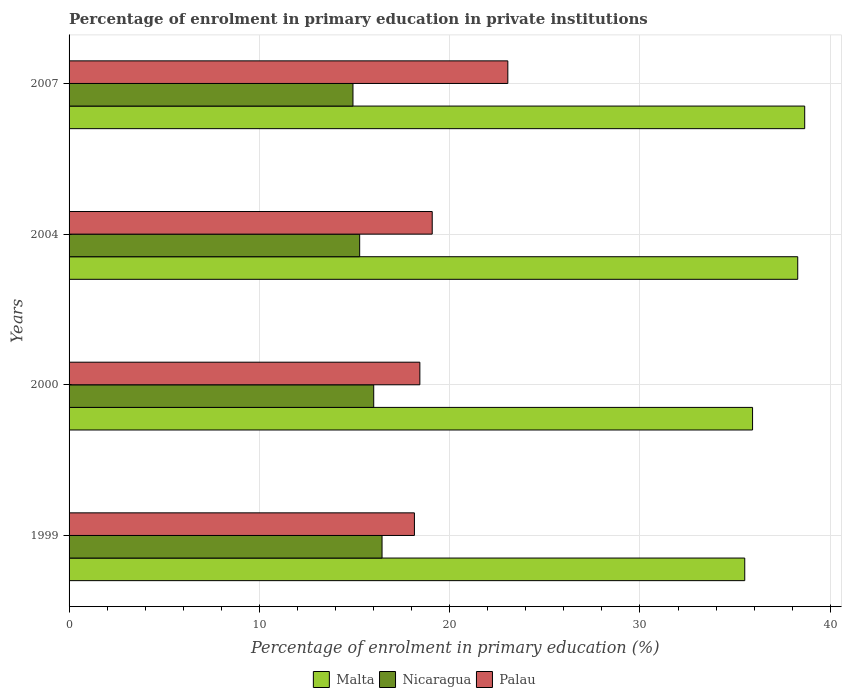How many different coloured bars are there?
Offer a very short reply. 3. How many groups of bars are there?
Give a very brief answer. 4. Are the number of bars on each tick of the Y-axis equal?
Offer a very short reply. Yes. How many bars are there on the 4th tick from the bottom?
Ensure brevity in your answer.  3. What is the label of the 1st group of bars from the top?
Offer a terse response. 2007. What is the percentage of enrolment in primary education in Palau in 2004?
Provide a short and direct response. 19.08. Across all years, what is the maximum percentage of enrolment in primary education in Nicaragua?
Make the answer very short. 16.45. Across all years, what is the minimum percentage of enrolment in primary education in Malta?
Your response must be concise. 35.51. In which year was the percentage of enrolment in primary education in Palau maximum?
Your answer should be compact. 2007. In which year was the percentage of enrolment in primary education in Nicaragua minimum?
Provide a short and direct response. 2007. What is the total percentage of enrolment in primary education in Malta in the graph?
Make the answer very short. 148.38. What is the difference between the percentage of enrolment in primary education in Nicaragua in 1999 and that in 2004?
Offer a very short reply. 1.18. What is the difference between the percentage of enrolment in primary education in Nicaragua in 2000 and the percentage of enrolment in primary education in Malta in 1999?
Offer a very short reply. -19.5. What is the average percentage of enrolment in primary education in Palau per year?
Ensure brevity in your answer.  19.68. In the year 2004, what is the difference between the percentage of enrolment in primary education in Malta and percentage of enrolment in primary education in Palau?
Give a very brief answer. 19.21. What is the ratio of the percentage of enrolment in primary education in Malta in 2000 to that in 2004?
Offer a terse response. 0.94. What is the difference between the highest and the second highest percentage of enrolment in primary education in Nicaragua?
Your response must be concise. 0.44. What is the difference between the highest and the lowest percentage of enrolment in primary education in Nicaragua?
Keep it short and to the point. 1.53. In how many years, is the percentage of enrolment in primary education in Nicaragua greater than the average percentage of enrolment in primary education in Nicaragua taken over all years?
Keep it short and to the point. 2. Is the sum of the percentage of enrolment in primary education in Nicaragua in 1999 and 2000 greater than the maximum percentage of enrolment in primary education in Palau across all years?
Your response must be concise. Yes. What does the 1st bar from the top in 2004 represents?
Your response must be concise. Palau. What does the 3rd bar from the bottom in 2004 represents?
Keep it short and to the point. Palau. Is it the case that in every year, the sum of the percentage of enrolment in primary education in Palau and percentage of enrolment in primary education in Malta is greater than the percentage of enrolment in primary education in Nicaragua?
Keep it short and to the point. Yes. How many bars are there?
Make the answer very short. 12. Are all the bars in the graph horizontal?
Your answer should be very brief. Yes. How many years are there in the graph?
Offer a terse response. 4. What is the title of the graph?
Keep it short and to the point. Percentage of enrolment in primary education in private institutions. Does "Sub-Saharan Africa (all income levels)" appear as one of the legend labels in the graph?
Provide a succinct answer. No. What is the label or title of the X-axis?
Make the answer very short. Percentage of enrolment in primary education (%). What is the label or title of the Y-axis?
Your response must be concise. Years. What is the Percentage of enrolment in primary education (%) in Malta in 1999?
Provide a short and direct response. 35.51. What is the Percentage of enrolment in primary education (%) of Nicaragua in 1999?
Your answer should be compact. 16.45. What is the Percentage of enrolment in primary education (%) of Palau in 1999?
Offer a terse response. 18.15. What is the Percentage of enrolment in primary education (%) of Malta in 2000?
Your answer should be compact. 35.92. What is the Percentage of enrolment in primary education (%) in Nicaragua in 2000?
Your response must be concise. 16.01. What is the Percentage of enrolment in primary education (%) in Palau in 2000?
Keep it short and to the point. 18.43. What is the Percentage of enrolment in primary education (%) in Malta in 2004?
Your response must be concise. 38.29. What is the Percentage of enrolment in primary education (%) in Nicaragua in 2004?
Ensure brevity in your answer.  15.27. What is the Percentage of enrolment in primary education (%) in Palau in 2004?
Your answer should be very brief. 19.08. What is the Percentage of enrolment in primary education (%) in Malta in 2007?
Your answer should be very brief. 38.66. What is the Percentage of enrolment in primary education (%) in Nicaragua in 2007?
Your response must be concise. 14.92. What is the Percentage of enrolment in primary education (%) in Palau in 2007?
Keep it short and to the point. 23.06. Across all years, what is the maximum Percentage of enrolment in primary education (%) in Malta?
Provide a succinct answer. 38.66. Across all years, what is the maximum Percentage of enrolment in primary education (%) in Nicaragua?
Your response must be concise. 16.45. Across all years, what is the maximum Percentage of enrolment in primary education (%) of Palau?
Keep it short and to the point. 23.06. Across all years, what is the minimum Percentage of enrolment in primary education (%) of Malta?
Provide a succinct answer. 35.51. Across all years, what is the minimum Percentage of enrolment in primary education (%) of Nicaragua?
Your answer should be compact. 14.92. Across all years, what is the minimum Percentage of enrolment in primary education (%) in Palau?
Make the answer very short. 18.15. What is the total Percentage of enrolment in primary education (%) in Malta in the graph?
Your response must be concise. 148.38. What is the total Percentage of enrolment in primary education (%) in Nicaragua in the graph?
Your answer should be very brief. 62.65. What is the total Percentage of enrolment in primary education (%) of Palau in the graph?
Provide a short and direct response. 78.72. What is the difference between the Percentage of enrolment in primary education (%) in Malta in 1999 and that in 2000?
Give a very brief answer. -0.41. What is the difference between the Percentage of enrolment in primary education (%) of Nicaragua in 1999 and that in 2000?
Keep it short and to the point. 0.44. What is the difference between the Percentage of enrolment in primary education (%) of Palau in 1999 and that in 2000?
Provide a short and direct response. -0.29. What is the difference between the Percentage of enrolment in primary education (%) of Malta in 1999 and that in 2004?
Make the answer very short. -2.78. What is the difference between the Percentage of enrolment in primary education (%) of Nicaragua in 1999 and that in 2004?
Make the answer very short. 1.18. What is the difference between the Percentage of enrolment in primary education (%) in Palau in 1999 and that in 2004?
Give a very brief answer. -0.94. What is the difference between the Percentage of enrolment in primary education (%) of Malta in 1999 and that in 2007?
Your response must be concise. -3.15. What is the difference between the Percentage of enrolment in primary education (%) of Nicaragua in 1999 and that in 2007?
Your answer should be compact. 1.53. What is the difference between the Percentage of enrolment in primary education (%) in Palau in 1999 and that in 2007?
Your answer should be compact. -4.91. What is the difference between the Percentage of enrolment in primary education (%) of Malta in 2000 and that in 2004?
Ensure brevity in your answer.  -2.37. What is the difference between the Percentage of enrolment in primary education (%) in Nicaragua in 2000 and that in 2004?
Keep it short and to the point. 0.74. What is the difference between the Percentage of enrolment in primary education (%) in Palau in 2000 and that in 2004?
Give a very brief answer. -0.65. What is the difference between the Percentage of enrolment in primary education (%) of Malta in 2000 and that in 2007?
Give a very brief answer. -2.74. What is the difference between the Percentage of enrolment in primary education (%) of Nicaragua in 2000 and that in 2007?
Offer a very short reply. 1.09. What is the difference between the Percentage of enrolment in primary education (%) in Palau in 2000 and that in 2007?
Provide a succinct answer. -4.62. What is the difference between the Percentage of enrolment in primary education (%) in Malta in 2004 and that in 2007?
Offer a terse response. -0.37. What is the difference between the Percentage of enrolment in primary education (%) in Nicaragua in 2004 and that in 2007?
Your response must be concise. 0.35. What is the difference between the Percentage of enrolment in primary education (%) of Palau in 2004 and that in 2007?
Your answer should be compact. -3.97. What is the difference between the Percentage of enrolment in primary education (%) of Malta in 1999 and the Percentage of enrolment in primary education (%) of Nicaragua in 2000?
Your answer should be very brief. 19.5. What is the difference between the Percentage of enrolment in primary education (%) of Malta in 1999 and the Percentage of enrolment in primary education (%) of Palau in 2000?
Offer a terse response. 17.07. What is the difference between the Percentage of enrolment in primary education (%) in Nicaragua in 1999 and the Percentage of enrolment in primary education (%) in Palau in 2000?
Offer a terse response. -1.99. What is the difference between the Percentage of enrolment in primary education (%) of Malta in 1999 and the Percentage of enrolment in primary education (%) of Nicaragua in 2004?
Your answer should be very brief. 20.24. What is the difference between the Percentage of enrolment in primary education (%) in Malta in 1999 and the Percentage of enrolment in primary education (%) in Palau in 2004?
Give a very brief answer. 16.42. What is the difference between the Percentage of enrolment in primary education (%) in Nicaragua in 1999 and the Percentage of enrolment in primary education (%) in Palau in 2004?
Provide a short and direct response. -2.64. What is the difference between the Percentage of enrolment in primary education (%) in Malta in 1999 and the Percentage of enrolment in primary education (%) in Nicaragua in 2007?
Ensure brevity in your answer.  20.59. What is the difference between the Percentage of enrolment in primary education (%) in Malta in 1999 and the Percentage of enrolment in primary education (%) in Palau in 2007?
Your answer should be compact. 12.45. What is the difference between the Percentage of enrolment in primary education (%) in Nicaragua in 1999 and the Percentage of enrolment in primary education (%) in Palau in 2007?
Offer a terse response. -6.61. What is the difference between the Percentage of enrolment in primary education (%) of Malta in 2000 and the Percentage of enrolment in primary education (%) of Nicaragua in 2004?
Keep it short and to the point. 20.65. What is the difference between the Percentage of enrolment in primary education (%) of Malta in 2000 and the Percentage of enrolment in primary education (%) of Palau in 2004?
Offer a terse response. 16.83. What is the difference between the Percentage of enrolment in primary education (%) in Nicaragua in 2000 and the Percentage of enrolment in primary education (%) in Palau in 2004?
Keep it short and to the point. -3.07. What is the difference between the Percentage of enrolment in primary education (%) in Malta in 2000 and the Percentage of enrolment in primary education (%) in Nicaragua in 2007?
Your answer should be very brief. 21. What is the difference between the Percentage of enrolment in primary education (%) of Malta in 2000 and the Percentage of enrolment in primary education (%) of Palau in 2007?
Offer a terse response. 12.86. What is the difference between the Percentage of enrolment in primary education (%) of Nicaragua in 2000 and the Percentage of enrolment in primary education (%) of Palau in 2007?
Offer a terse response. -7.05. What is the difference between the Percentage of enrolment in primary education (%) of Malta in 2004 and the Percentage of enrolment in primary education (%) of Nicaragua in 2007?
Your answer should be very brief. 23.37. What is the difference between the Percentage of enrolment in primary education (%) in Malta in 2004 and the Percentage of enrolment in primary education (%) in Palau in 2007?
Keep it short and to the point. 15.23. What is the difference between the Percentage of enrolment in primary education (%) of Nicaragua in 2004 and the Percentage of enrolment in primary education (%) of Palau in 2007?
Your response must be concise. -7.79. What is the average Percentage of enrolment in primary education (%) of Malta per year?
Provide a succinct answer. 37.09. What is the average Percentage of enrolment in primary education (%) of Nicaragua per year?
Provide a short and direct response. 15.66. What is the average Percentage of enrolment in primary education (%) of Palau per year?
Provide a short and direct response. 19.68. In the year 1999, what is the difference between the Percentage of enrolment in primary education (%) of Malta and Percentage of enrolment in primary education (%) of Nicaragua?
Keep it short and to the point. 19.06. In the year 1999, what is the difference between the Percentage of enrolment in primary education (%) in Malta and Percentage of enrolment in primary education (%) in Palau?
Your answer should be very brief. 17.36. In the year 1999, what is the difference between the Percentage of enrolment in primary education (%) of Nicaragua and Percentage of enrolment in primary education (%) of Palau?
Ensure brevity in your answer.  -1.7. In the year 2000, what is the difference between the Percentage of enrolment in primary education (%) in Malta and Percentage of enrolment in primary education (%) in Nicaragua?
Give a very brief answer. 19.91. In the year 2000, what is the difference between the Percentage of enrolment in primary education (%) of Malta and Percentage of enrolment in primary education (%) of Palau?
Give a very brief answer. 17.48. In the year 2000, what is the difference between the Percentage of enrolment in primary education (%) of Nicaragua and Percentage of enrolment in primary education (%) of Palau?
Your answer should be very brief. -2.43. In the year 2004, what is the difference between the Percentage of enrolment in primary education (%) in Malta and Percentage of enrolment in primary education (%) in Nicaragua?
Give a very brief answer. 23.02. In the year 2004, what is the difference between the Percentage of enrolment in primary education (%) in Malta and Percentage of enrolment in primary education (%) in Palau?
Provide a short and direct response. 19.21. In the year 2004, what is the difference between the Percentage of enrolment in primary education (%) in Nicaragua and Percentage of enrolment in primary education (%) in Palau?
Keep it short and to the point. -3.81. In the year 2007, what is the difference between the Percentage of enrolment in primary education (%) in Malta and Percentage of enrolment in primary education (%) in Nicaragua?
Make the answer very short. 23.74. In the year 2007, what is the difference between the Percentage of enrolment in primary education (%) in Malta and Percentage of enrolment in primary education (%) in Palau?
Offer a very short reply. 15.6. In the year 2007, what is the difference between the Percentage of enrolment in primary education (%) in Nicaragua and Percentage of enrolment in primary education (%) in Palau?
Provide a succinct answer. -8.14. What is the ratio of the Percentage of enrolment in primary education (%) of Nicaragua in 1999 to that in 2000?
Your answer should be compact. 1.03. What is the ratio of the Percentage of enrolment in primary education (%) of Palau in 1999 to that in 2000?
Make the answer very short. 0.98. What is the ratio of the Percentage of enrolment in primary education (%) in Malta in 1999 to that in 2004?
Offer a terse response. 0.93. What is the ratio of the Percentage of enrolment in primary education (%) of Nicaragua in 1999 to that in 2004?
Your answer should be very brief. 1.08. What is the ratio of the Percentage of enrolment in primary education (%) in Palau in 1999 to that in 2004?
Your answer should be very brief. 0.95. What is the ratio of the Percentage of enrolment in primary education (%) of Malta in 1999 to that in 2007?
Your answer should be compact. 0.92. What is the ratio of the Percentage of enrolment in primary education (%) in Nicaragua in 1999 to that in 2007?
Give a very brief answer. 1.1. What is the ratio of the Percentage of enrolment in primary education (%) in Palau in 1999 to that in 2007?
Your answer should be compact. 0.79. What is the ratio of the Percentage of enrolment in primary education (%) in Malta in 2000 to that in 2004?
Your response must be concise. 0.94. What is the ratio of the Percentage of enrolment in primary education (%) in Nicaragua in 2000 to that in 2004?
Your response must be concise. 1.05. What is the ratio of the Percentage of enrolment in primary education (%) in Palau in 2000 to that in 2004?
Your response must be concise. 0.97. What is the ratio of the Percentage of enrolment in primary education (%) in Malta in 2000 to that in 2007?
Your answer should be very brief. 0.93. What is the ratio of the Percentage of enrolment in primary education (%) in Nicaragua in 2000 to that in 2007?
Keep it short and to the point. 1.07. What is the ratio of the Percentage of enrolment in primary education (%) of Palau in 2000 to that in 2007?
Keep it short and to the point. 0.8. What is the ratio of the Percentage of enrolment in primary education (%) in Nicaragua in 2004 to that in 2007?
Your answer should be very brief. 1.02. What is the ratio of the Percentage of enrolment in primary education (%) of Palau in 2004 to that in 2007?
Give a very brief answer. 0.83. What is the difference between the highest and the second highest Percentage of enrolment in primary education (%) in Malta?
Your answer should be very brief. 0.37. What is the difference between the highest and the second highest Percentage of enrolment in primary education (%) in Nicaragua?
Ensure brevity in your answer.  0.44. What is the difference between the highest and the second highest Percentage of enrolment in primary education (%) in Palau?
Give a very brief answer. 3.97. What is the difference between the highest and the lowest Percentage of enrolment in primary education (%) of Malta?
Ensure brevity in your answer.  3.15. What is the difference between the highest and the lowest Percentage of enrolment in primary education (%) of Nicaragua?
Your response must be concise. 1.53. What is the difference between the highest and the lowest Percentage of enrolment in primary education (%) of Palau?
Your response must be concise. 4.91. 